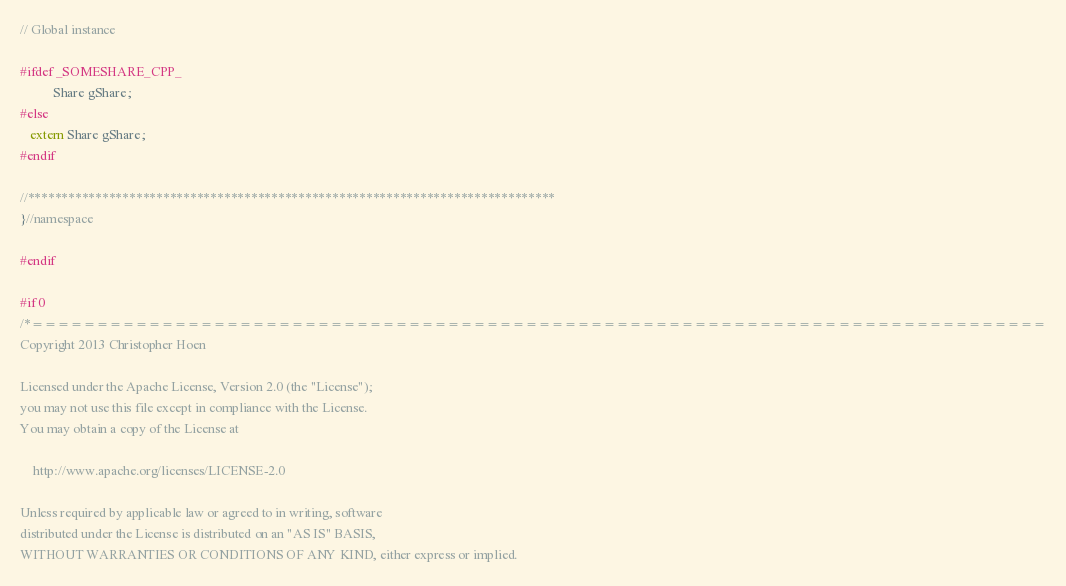<code> <loc_0><loc_0><loc_500><loc_500><_C_>// Global instance

#ifdef _SOMESHARE_CPP_
          Share gShare;
#else
   extern Share gShare;
#endif

//******************************************************************************
}//namespace

#endif

#if 0
/*==============================================================================
Copyright 2013 Christopher Hoen

Licensed under the Apache License, Version 2.0 (the "License");
you may not use this file except in compliance with the License.
You may obtain a copy of the License at

    http://www.apache.org/licenses/LICENSE-2.0

Unless required by applicable law or agreed to in writing, software
distributed under the License is distributed on an "AS IS" BASIS,
WITHOUT WARRANTIES OR CONDITIONS OF ANY KIND, either express or implied.</code> 